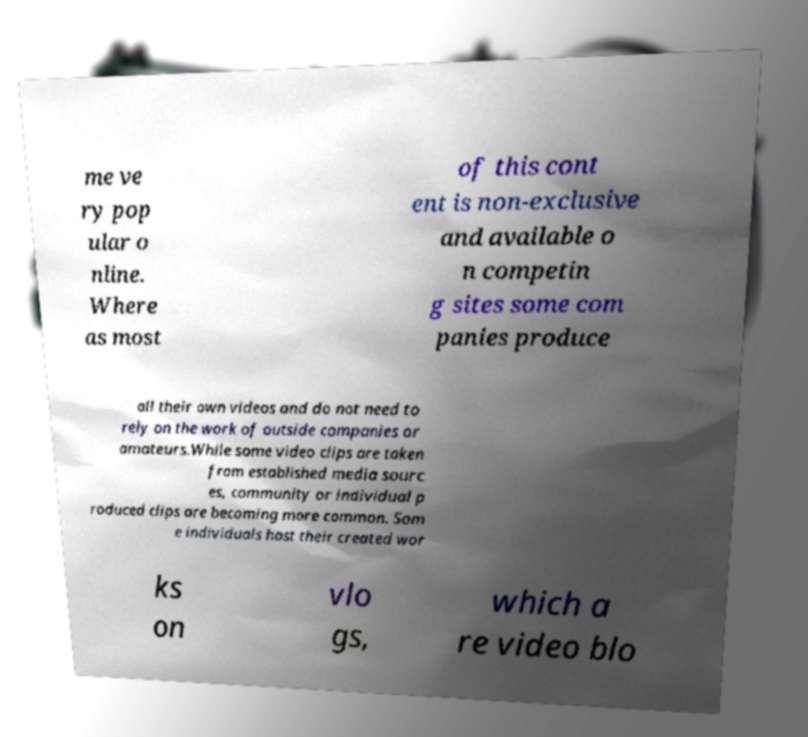Can you accurately transcribe the text from the provided image for me? me ve ry pop ular o nline. Where as most of this cont ent is non-exclusive and available o n competin g sites some com panies produce all their own videos and do not need to rely on the work of outside companies or amateurs.While some video clips are taken from established media sourc es, community or individual p roduced clips are becoming more common. Som e individuals host their created wor ks on vlo gs, which a re video blo 